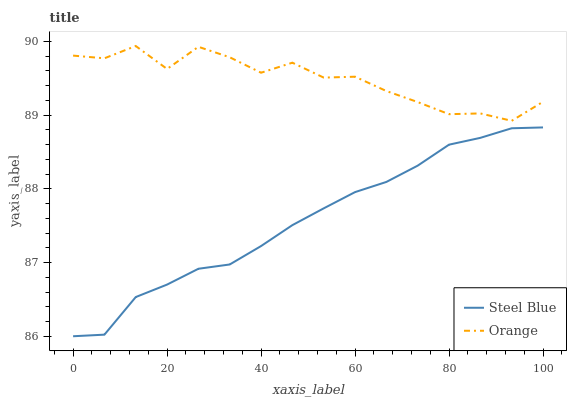Does Steel Blue have the minimum area under the curve?
Answer yes or no. Yes. Does Orange have the maximum area under the curve?
Answer yes or no. Yes. Does Steel Blue have the maximum area under the curve?
Answer yes or no. No. Is Steel Blue the smoothest?
Answer yes or no. Yes. Is Orange the roughest?
Answer yes or no. Yes. Is Steel Blue the roughest?
Answer yes or no. No. Does Orange have the highest value?
Answer yes or no. Yes. Does Steel Blue have the highest value?
Answer yes or no. No. Is Steel Blue less than Orange?
Answer yes or no. Yes. Is Orange greater than Steel Blue?
Answer yes or no. Yes. Does Steel Blue intersect Orange?
Answer yes or no. No. 